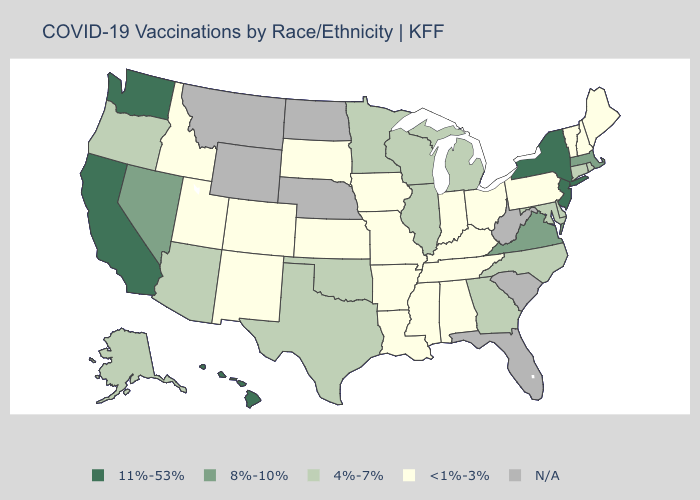Name the states that have a value in the range 11%-53%?
Keep it brief. California, Hawaii, New Jersey, New York, Washington. What is the value of Minnesota?
Answer briefly. 4%-7%. What is the lowest value in the MidWest?
Write a very short answer. <1%-3%. Name the states that have a value in the range 4%-7%?
Short answer required. Alaska, Arizona, Connecticut, Delaware, Georgia, Illinois, Maryland, Michigan, Minnesota, North Carolina, Oklahoma, Oregon, Rhode Island, Texas, Wisconsin. Among the states that border Tennessee , does Virginia have the lowest value?
Write a very short answer. No. Name the states that have a value in the range <1%-3%?
Concise answer only. Alabama, Arkansas, Colorado, Idaho, Indiana, Iowa, Kansas, Kentucky, Louisiana, Maine, Mississippi, Missouri, New Hampshire, New Mexico, Ohio, Pennsylvania, South Dakota, Tennessee, Utah, Vermont. Among the states that border Nevada , does Utah have the lowest value?
Write a very short answer. Yes. Which states have the lowest value in the South?
Quick response, please. Alabama, Arkansas, Kentucky, Louisiana, Mississippi, Tennessee. Name the states that have a value in the range N/A?
Keep it brief. Florida, Montana, Nebraska, North Dakota, South Carolina, West Virginia, Wyoming. What is the value of Michigan?
Keep it brief. 4%-7%. What is the lowest value in the South?
Short answer required. <1%-3%. Is the legend a continuous bar?
Quick response, please. No. Which states hav the highest value in the South?
Give a very brief answer. Virginia. What is the lowest value in the Northeast?
Keep it brief. <1%-3%. 